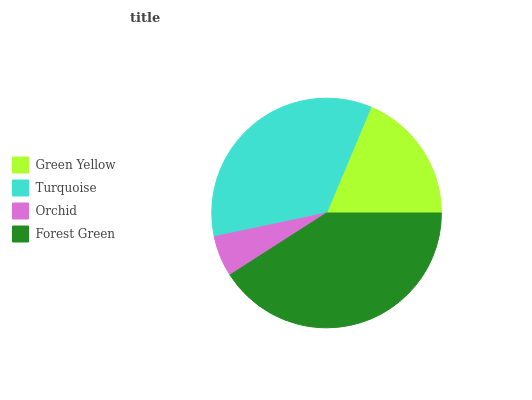Is Orchid the minimum?
Answer yes or no. Yes. Is Forest Green the maximum?
Answer yes or no. Yes. Is Turquoise the minimum?
Answer yes or no. No. Is Turquoise the maximum?
Answer yes or no. No. Is Turquoise greater than Green Yellow?
Answer yes or no. Yes. Is Green Yellow less than Turquoise?
Answer yes or no. Yes. Is Green Yellow greater than Turquoise?
Answer yes or no. No. Is Turquoise less than Green Yellow?
Answer yes or no. No. Is Turquoise the high median?
Answer yes or no. Yes. Is Green Yellow the low median?
Answer yes or no. Yes. Is Forest Green the high median?
Answer yes or no. No. Is Orchid the low median?
Answer yes or no. No. 